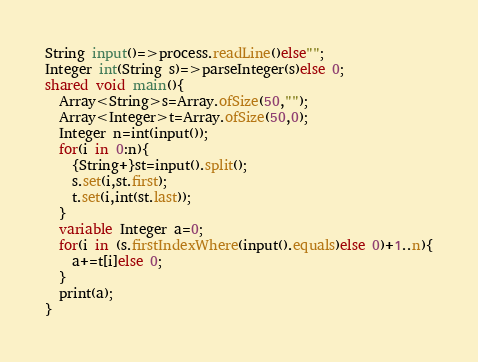<code> <loc_0><loc_0><loc_500><loc_500><_Ceylon_>String input()=>process.readLine()else""; 
Integer int(String s)=>parseInteger(s)else 0;
shared void main(){
  Array<String>s=Array.ofSize(50,"");
  Array<Integer>t=Array.ofSize(50,0);
  Integer n=int(input());
  for(i in 0:n){
    {String+}st=input().split();
    s.set(i,st.first);
    t.set(i,int(st.last));
  }
  variable Integer a=0;
  for(i in (s.firstIndexWhere(input().equals)else 0)+1..n){
    a+=t[i]else 0;
  }
  print(a);
}</code> 